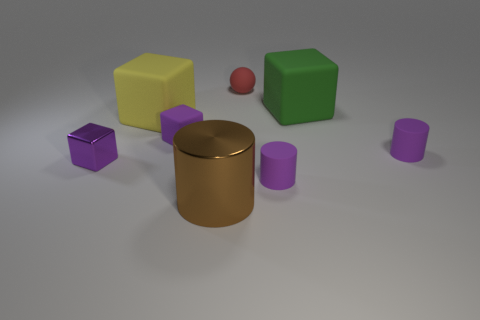Subtract all tiny matte blocks. How many blocks are left? 3 Add 1 purple matte cubes. How many objects exist? 9 Subtract all purple cylinders. How many cylinders are left? 1 Subtract all spheres. How many objects are left? 7 Subtract all cyan balls. Subtract all purple blocks. How many balls are left? 1 Subtract all blue balls. How many gray cubes are left? 0 Subtract all purple metallic cubes. Subtract all purple shiny spheres. How many objects are left? 7 Add 5 tiny red objects. How many tiny red objects are left? 6 Add 8 big green cylinders. How many big green cylinders exist? 8 Subtract 0 gray blocks. How many objects are left? 8 